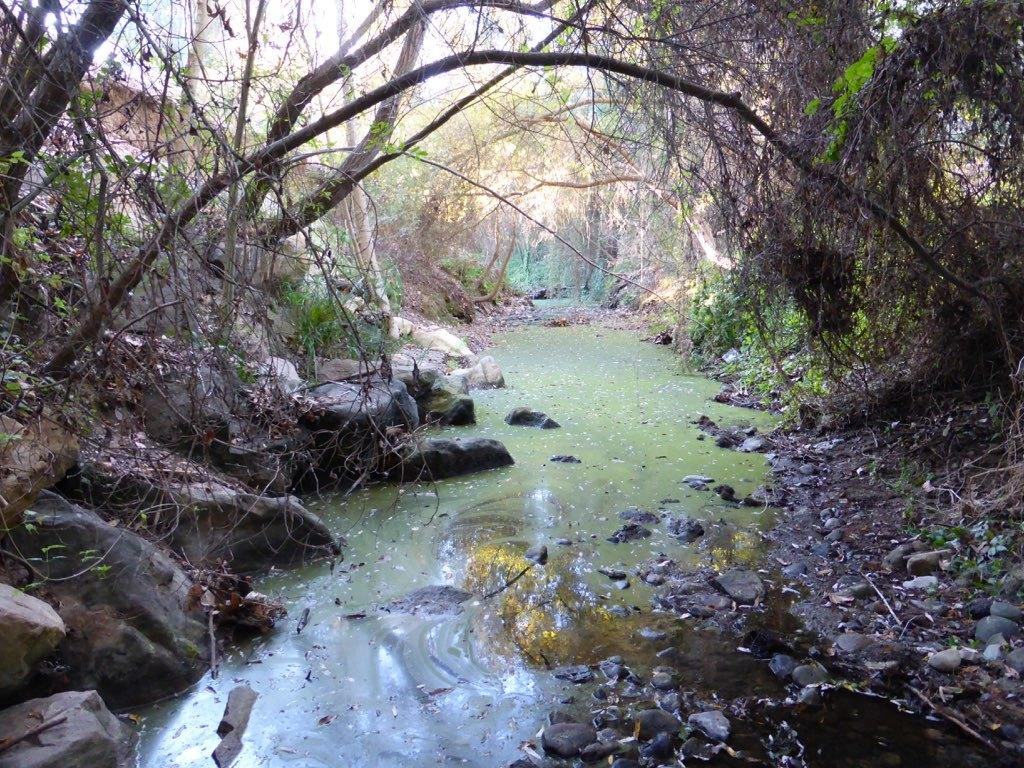What is present in the image that is not solid? There is water in the image. What can be seen floating in the water? There is algae in the water. What type of vegetation is visible in the image? There are trees in the image. What type of natural formation can be seen in the image? There are rocks in the image. Can you see any zephyrs blowing through the trees in the image? There are no zephyrs present in the image. What type of coat is being worn by the algae in the water? The algae in the water do not wear coats, as they are not living beings capable of wearing clothing. 